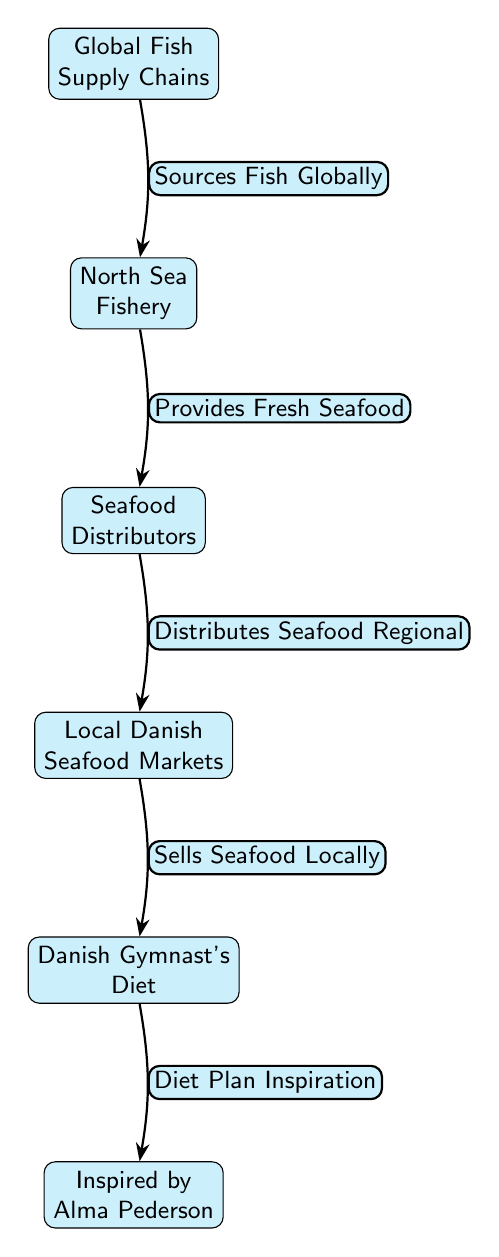What is at the top of the hierarchy? The diagram depicts a hierarchy where the top node is "Global Fish Supply Chains." This note represents the source of fish globally before they are distributed further down the chain.
Answer: Global Fish Supply Chains How many nodes are in the diagram? The diagram contains five nodes in total, which are: 1) Global Fish Supply Chains, 2) North Sea Fishery, 3) Seafood Distributors, 4) Local Danish Seafood Markets, and 5) Danish Gymnast's Diet.
Answer: 5 What relationship exists between "Seafood Distributors" and "Local Danish Seafood Markets"? The diagram indicates that Seafood Distributors "Distributes Seafood Regional," which implies a direct relationship where distributors provide seafood to local markets for sale.
Answer: Distributes Seafood Regional What is the last node in the flow? The last node within the flow of the diagram represents "Inspired by Alma Pederson," which emphasizes the influence of the previous dietary information on the gymnast’s inspiration.
Answer: Inspired by Alma Pederson What does "North Sea Fishery" provide? According to the diagram, the North Sea Fishery "Provides Fresh Seafood," which signifies its role in supplying seafood to the next stage in the diagram.
Answer: Provides Fresh Seafood How do local seafood markets influence a Danish gymnast's diet? The diagram shows that local seafood markets "Sells Seafood Locally," which directly impacts the contents of the Danish gymnast's diet, allowing her access to fresh seafood for her nutrition.
Answer: Sells Seafood Locally Which node implies the source of fish? The top node, "Global Fish Supply Chains," serves as the primary source of fish that flows down the supply chain to local markets and ultimately to the gymnast's diet.
Answer: Global Fish Supply Chains What connects "Danish Gymnast's Diet" to "Inspired by Alma Pederson"? The connection shows that the Danish Gymnast's Diet influences or draws inspiration from the achievements or philosophy of Alma Pederson, marking a motivational link.
Answer: Diet Plan Inspiration 